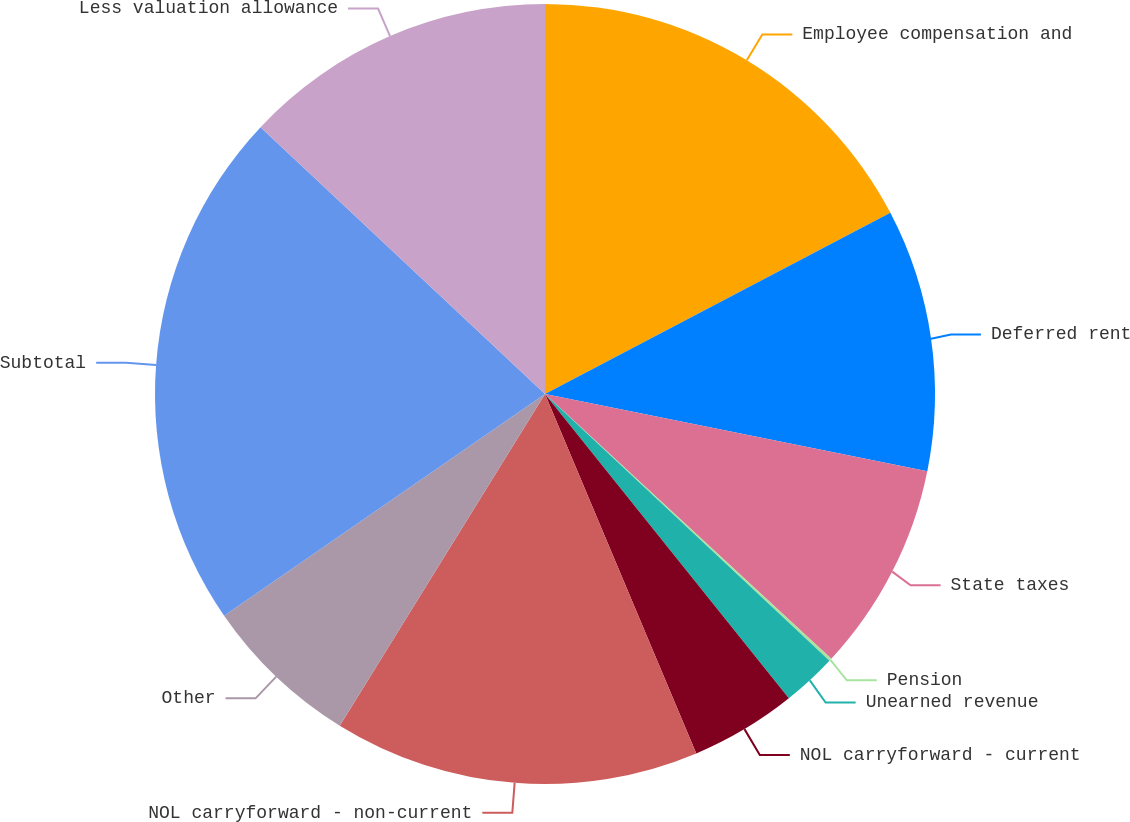Convert chart to OTSL. <chart><loc_0><loc_0><loc_500><loc_500><pie_chart><fcel>Employee compensation and<fcel>Deferred rent<fcel>State taxes<fcel>Pension<fcel>Unearned revenue<fcel>NOL carryforward - current<fcel>NOL carryforward - non-current<fcel>Other<fcel>Subtotal<fcel>Less valuation allowance<nl><fcel>17.31%<fcel>10.86%<fcel>8.71%<fcel>0.11%<fcel>2.26%<fcel>4.41%<fcel>15.16%<fcel>6.56%<fcel>21.61%<fcel>13.01%<nl></chart> 